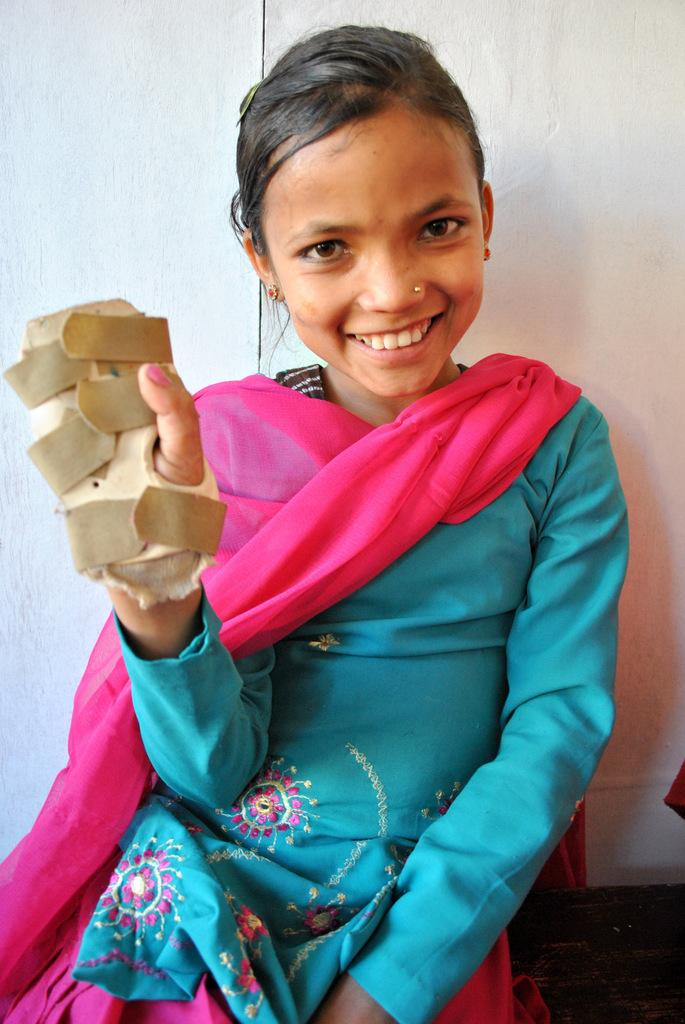Who is the main subject in the image? There is a girl in the image. What is the girl wearing? The girl is wearing a blue and pink color dress. Are there any accessories visible in the image? Yes, the girl is wearing gloves. What type of pet can be seen playing with the girl in the image? There is no pet visible in the image; it only features the girl wearing a blue and pink dress and gloves. 